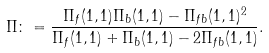<formula> <loc_0><loc_0><loc_500><loc_500>\Pi \colon = \frac { \Pi _ { f } ( 1 , 1 ) \Pi _ { b } ( 1 , 1 ) - \Pi _ { f b } ( 1 , 1 ) ^ { 2 } } { \Pi _ { f } ( 1 , 1 ) + \Pi _ { b } ( 1 , 1 ) - 2 \Pi _ { f b } ( 1 , 1 ) } .</formula> 